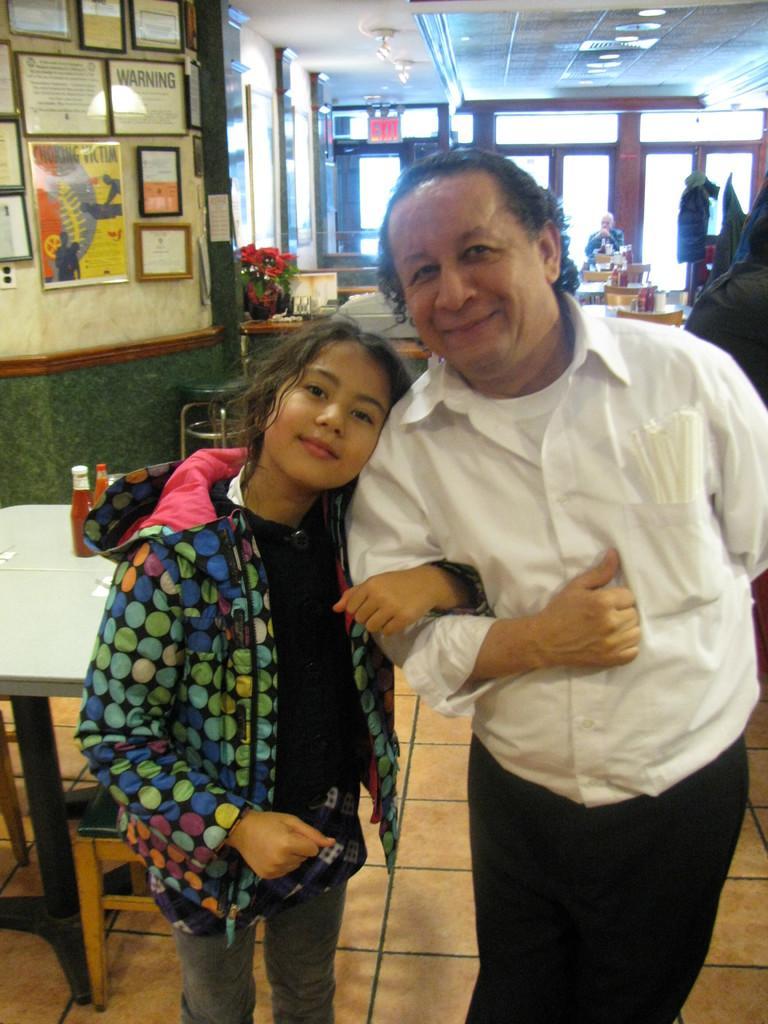How would you summarize this image in a sentence or two? At the top we can see ceiling, lights. these are doors. Here we can see photo frames over a wall. And on the table we can see bottles, flower vase. We can see a man and a girl standing on a floor and smiling. 